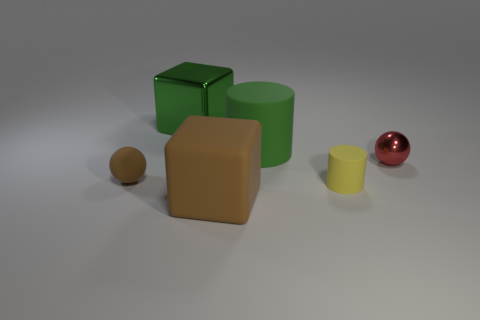Add 2 yellow cylinders. How many objects exist? 8 Subtract all cylinders. How many objects are left? 4 Subtract 1 red balls. How many objects are left? 5 Subtract all large green metal things. Subtract all yellow matte cylinders. How many objects are left? 4 Add 3 large green metal blocks. How many large green metal blocks are left? 4 Add 6 large blue metal objects. How many large blue metal objects exist? 6 